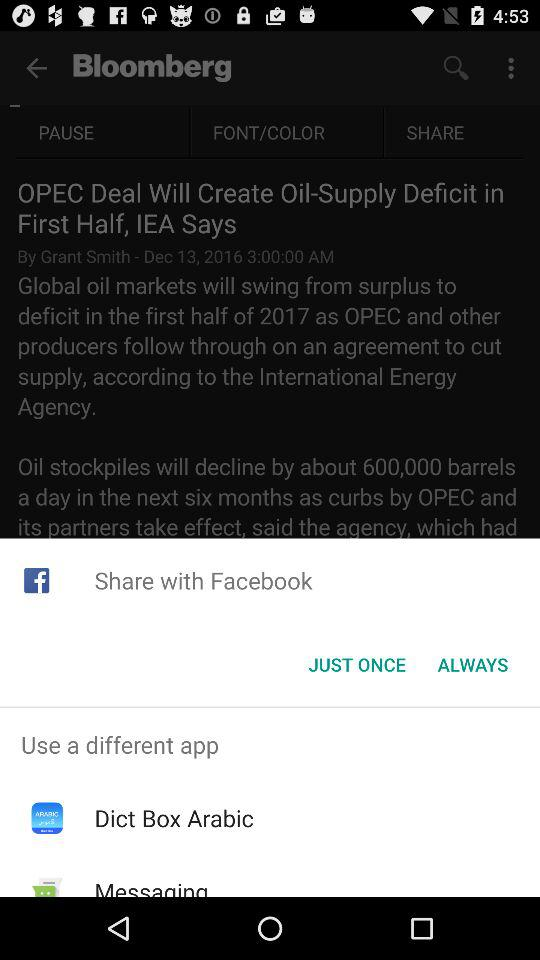Through which application can the content be shared? The applications through which the content can be shared are "Facebook", "Dict Box Arabic", and "Messaging". 